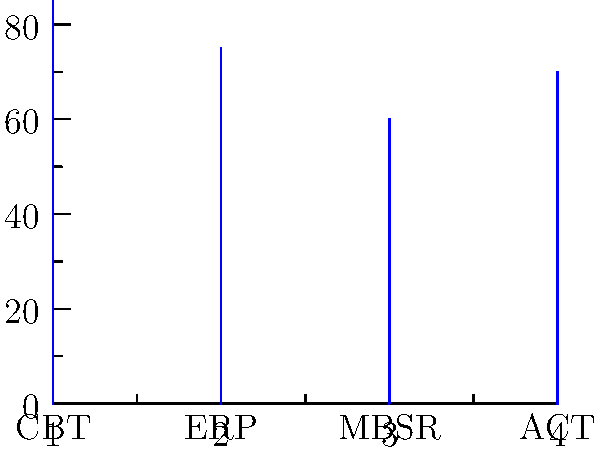Based on the graph showing the effectiveness of different therapy types for anxiety disorders, which therapy appears to be the most effective, and what implications might this have for treatment recommendations in clinical practice? To answer this question, we need to analyze the graph and interpret its implications for clinical practice. Let's break it down step-by-step:

1. Examine the graph:
   The graph shows four therapy types: CBT (Cognitive Behavioral Therapy), ERP (Exposure and Response Prevention), MBSR (Mindfulness-Based Stress Reduction), and ACT (Acceptance and Commitment Therapy).

2. Compare effectiveness percentages:
   - CBT: approximately 85%
   - ERP: approximately 75%
   - MBSR: approximately 60%
   - ACT: approximately 70%

3. Identify the most effective therapy:
   Based on the graph, CBT (Cognitive Behavioral Therapy) appears to be the most effective, with an effectiveness rate of about 85%.

4. Implications for treatment recommendations:
   a) Primary recommendation: As CBT shows the highest effectiveness, it should be considered as the first-line treatment for anxiety disorders in most cases.
   
   b) Personalized approach: While CBT is most effective overall, other therapies still show significant effectiveness. This suggests that a personalized approach, considering individual patient needs and preferences, may be beneficial.
   
   c) Combination therapies: The high effectiveness of multiple therapies might indicate that combining approaches (e.g., CBT with MBSR) could be explored for potentially enhanced outcomes.
   
   d) Resource allocation: Mental health services might consider prioritizing training and resources for CBT, given its high effectiveness.
   
   e) Patient education: Clinicians should educate patients about the effectiveness of different therapies to inform shared decision-making in treatment planning.
   
   f) Research directions: Further research could focus on understanding why CBT is more effective and how to improve other therapy types or integrate their most effective elements.

5. Limitations to consider:
   This graph provides a general overview, but individual responses to therapy can vary. Factors such as comorbidities, severity of anxiety, and specific anxiety disorders are not accounted for in this simplified representation.
Answer: CBT is most effective; recommend as primary treatment, but consider personalized approaches and potential combination therapies. 